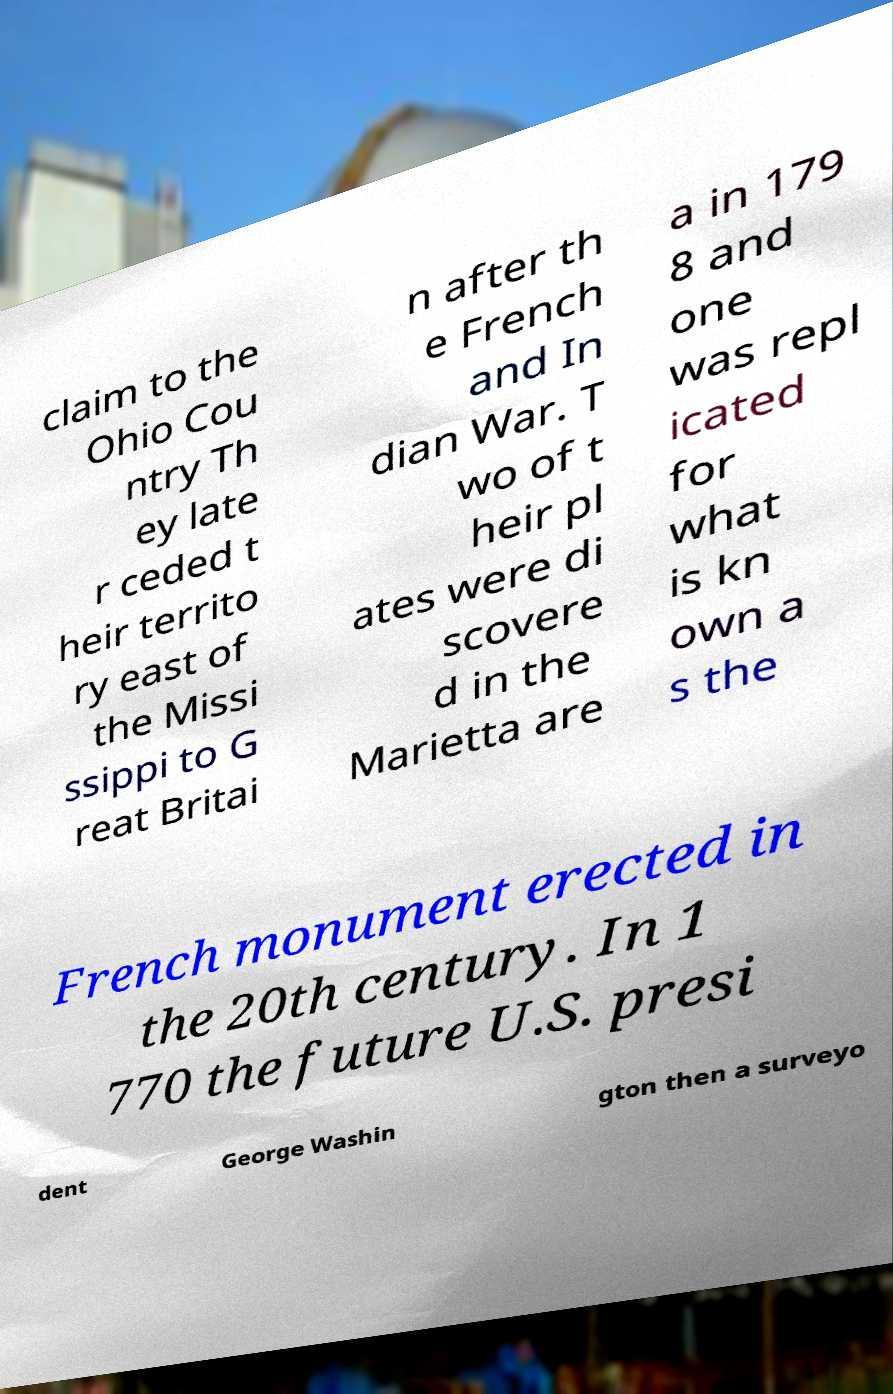There's text embedded in this image that I need extracted. Can you transcribe it verbatim? claim to the Ohio Cou ntry Th ey late r ceded t heir territo ry east of the Missi ssippi to G reat Britai n after th e French and In dian War. T wo of t heir pl ates were di scovere d in the Marietta are a in 179 8 and one was repl icated for what is kn own a s the French monument erected in the 20th century. In 1 770 the future U.S. presi dent George Washin gton then a surveyo 